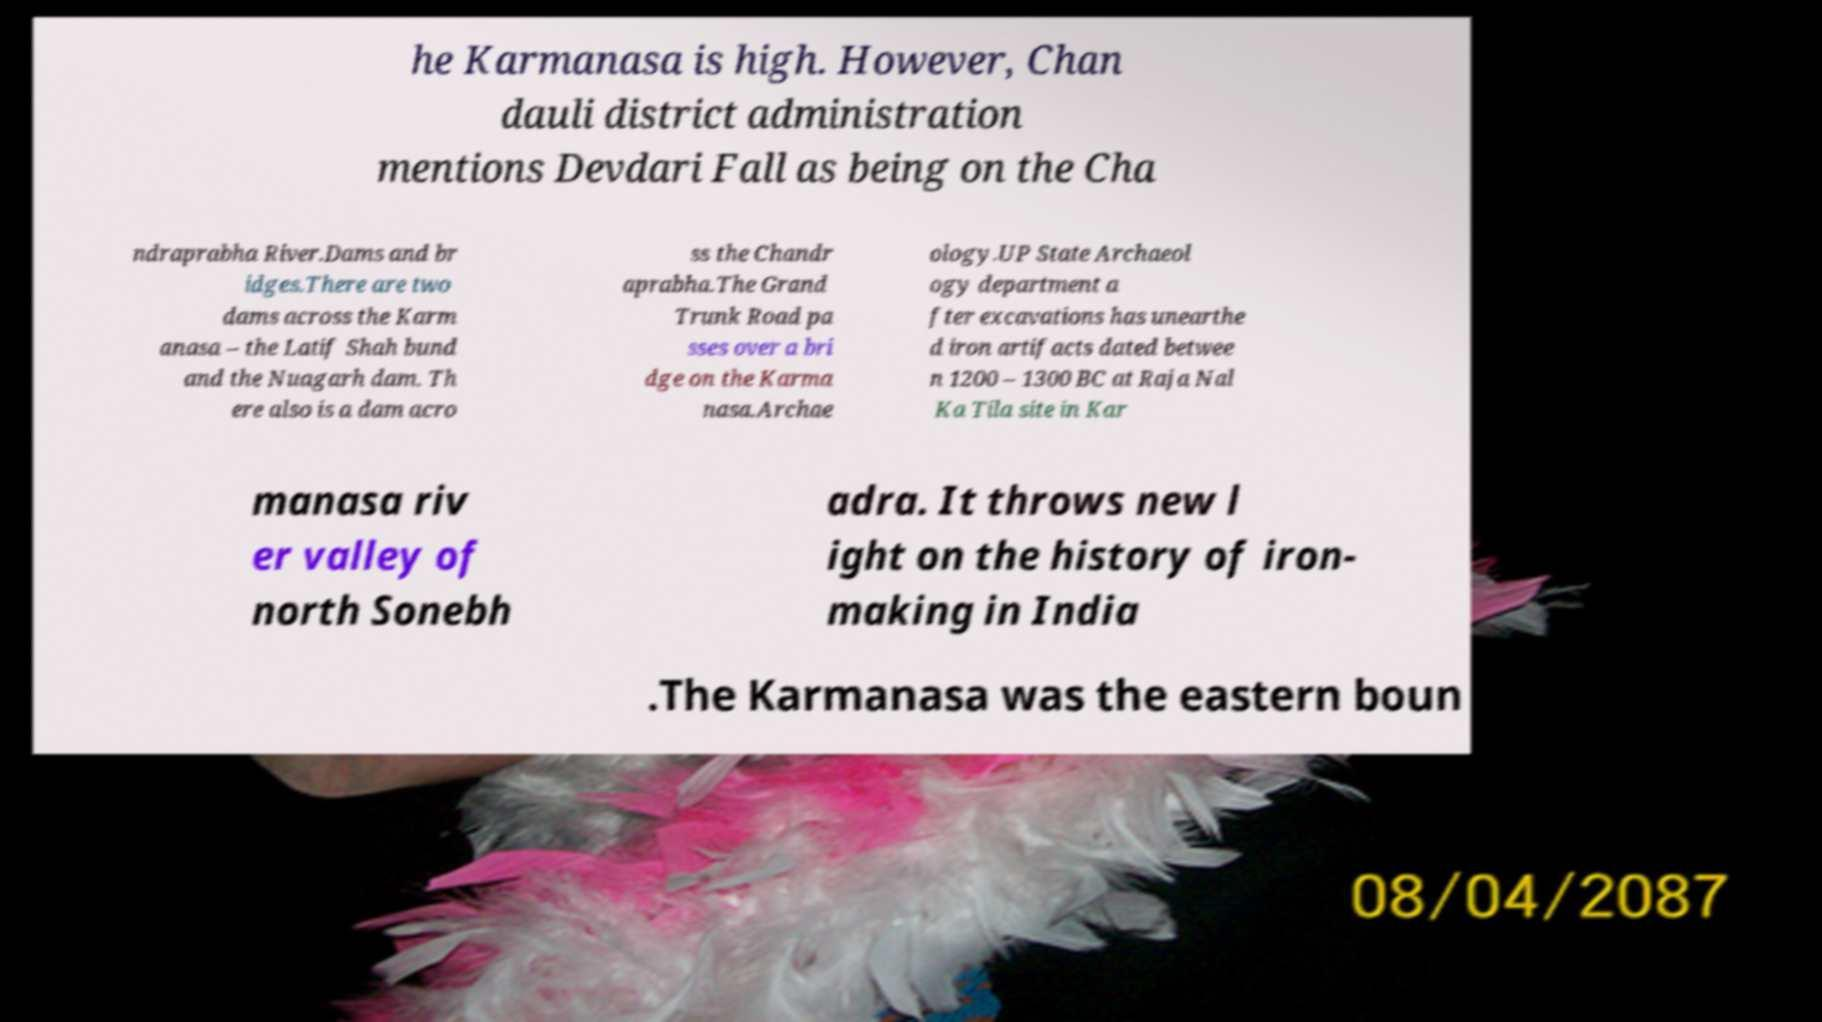Please read and relay the text visible in this image. What does it say? he Karmanasa is high. However, Chan dauli district administration mentions Devdari Fall as being on the Cha ndraprabha River.Dams and br idges.There are two dams across the Karm anasa – the Latif Shah bund and the Nuagarh dam. Th ere also is a dam acro ss the Chandr aprabha.The Grand Trunk Road pa sses over a bri dge on the Karma nasa.Archae ology.UP State Archaeol ogy department a fter excavations has unearthe d iron artifacts dated betwee n 1200 – 1300 BC at Raja Nal Ka Tila site in Kar manasa riv er valley of north Sonebh adra. It throws new l ight on the history of iron- making in India .The Karmanasa was the eastern boun 